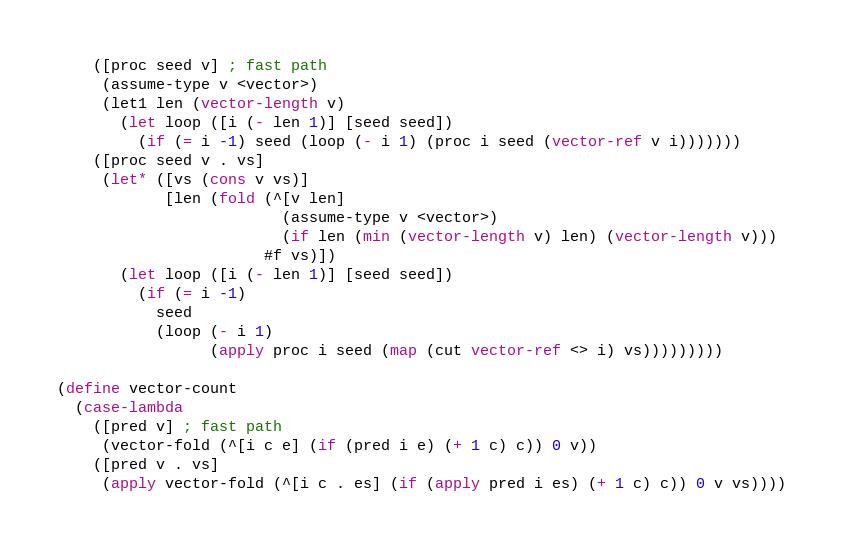Convert code to text. <code><loc_0><loc_0><loc_500><loc_500><_Scheme_>    ([proc seed v] ; fast path
     (assume-type v <vector>)
     (let1 len (vector-length v)
       (let loop ([i (- len 1)] [seed seed])
         (if (= i -1) seed (loop (- i 1) (proc i seed (vector-ref v i)))))))
    ([proc seed v . vs]
     (let* ([vs (cons v vs)]
            [len (fold (^[v len]
                         (assume-type v <vector>)
                         (if len (min (vector-length v) len) (vector-length v)))
                       #f vs)])
       (let loop ([i (- len 1)] [seed seed])
         (if (= i -1)
           seed
           (loop (- i 1)
                 (apply proc i seed (map (cut vector-ref <> i) vs)))))))))

(define vector-count
  (case-lambda
    ([pred v] ; fast path
     (vector-fold (^[i c e] (if (pred i e) (+ 1 c) c)) 0 v))
    ([pred v . vs]
     (apply vector-fold (^[i c . es] (if (apply pred i es) (+ 1 c) c)) 0 v vs))))
</code> 